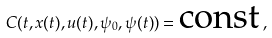<formula> <loc_0><loc_0><loc_500><loc_500>C ( t , x ( t ) , u ( t ) , \psi _ { 0 } , \psi ( t ) ) = \text {const} \, ,</formula> 